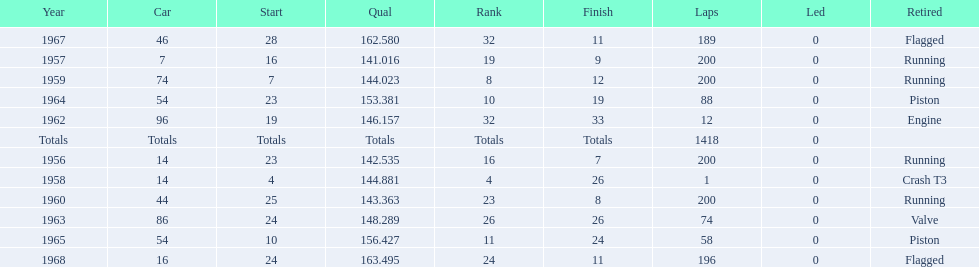How many times did he finish all 200 laps? 4. Would you be able to parse every entry in this table? {'header': ['Year', 'Car', 'Start', 'Qual', 'Rank', 'Finish', 'Laps', 'Led', 'Retired'], 'rows': [['1967', '46', '28', '162.580', '32', '11', '189', '0', 'Flagged'], ['1957', '7', '16', '141.016', '19', '9', '200', '0', 'Running'], ['1959', '74', '7', '144.023', '8', '12', '200', '0', 'Running'], ['1964', '54', '23', '153.381', '10', '19', '88', '0', 'Piston'], ['1962', '96', '19', '146.157', '32', '33', '12', '0', 'Engine'], ['Totals', 'Totals', 'Totals', 'Totals', 'Totals', 'Totals', '1418', '0', ''], ['1956', '14', '23', '142.535', '16', '7', '200', '0', 'Running'], ['1958', '14', '4', '144.881', '4', '26', '1', '0', 'Crash T3'], ['1960', '44', '25', '143.363', '23', '8', '200', '0', 'Running'], ['1963', '86', '24', '148.289', '26', '26', '74', '0', 'Valve'], ['1965', '54', '10', '156.427', '11', '24', '58', '0', 'Piston'], ['1968', '16', '24', '163.495', '24', '11', '196', '0', 'Flagged']]} 